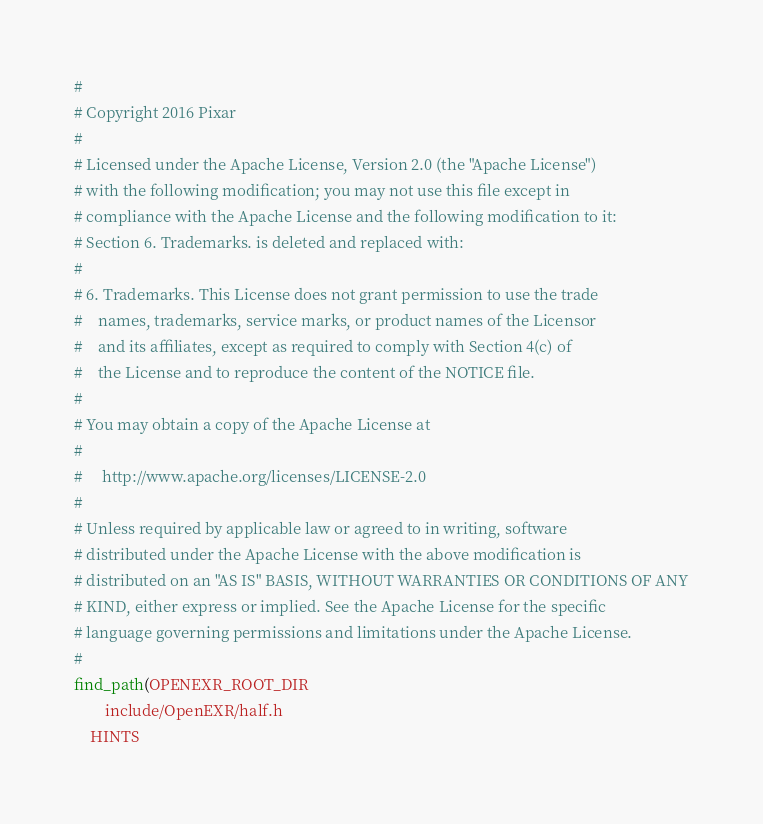<code> <loc_0><loc_0><loc_500><loc_500><_CMake_>#
# Copyright 2016 Pixar
#
# Licensed under the Apache License, Version 2.0 (the "Apache License")
# with the following modification; you may not use this file except in
# compliance with the Apache License and the following modification to it:
# Section 6. Trademarks. is deleted and replaced with:
#
# 6. Trademarks. This License does not grant permission to use the trade
#    names, trademarks, service marks, or product names of the Licensor
#    and its affiliates, except as required to comply with Section 4(c) of
#    the License and to reproduce the content of the NOTICE file.
#
# You may obtain a copy of the Apache License at
#
#     http://www.apache.org/licenses/LICENSE-2.0
#
# Unless required by applicable law or agreed to in writing, software
# distributed under the Apache License with the above modification is
# distributed on an "AS IS" BASIS, WITHOUT WARRANTIES OR CONDITIONS OF ANY
# KIND, either express or implied. See the Apache License for the specific
# language governing permissions and limitations under the Apache License.
#
find_path(OPENEXR_ROOT_DIR
        include/OpenEXR/half.h
    HINTS</code> 